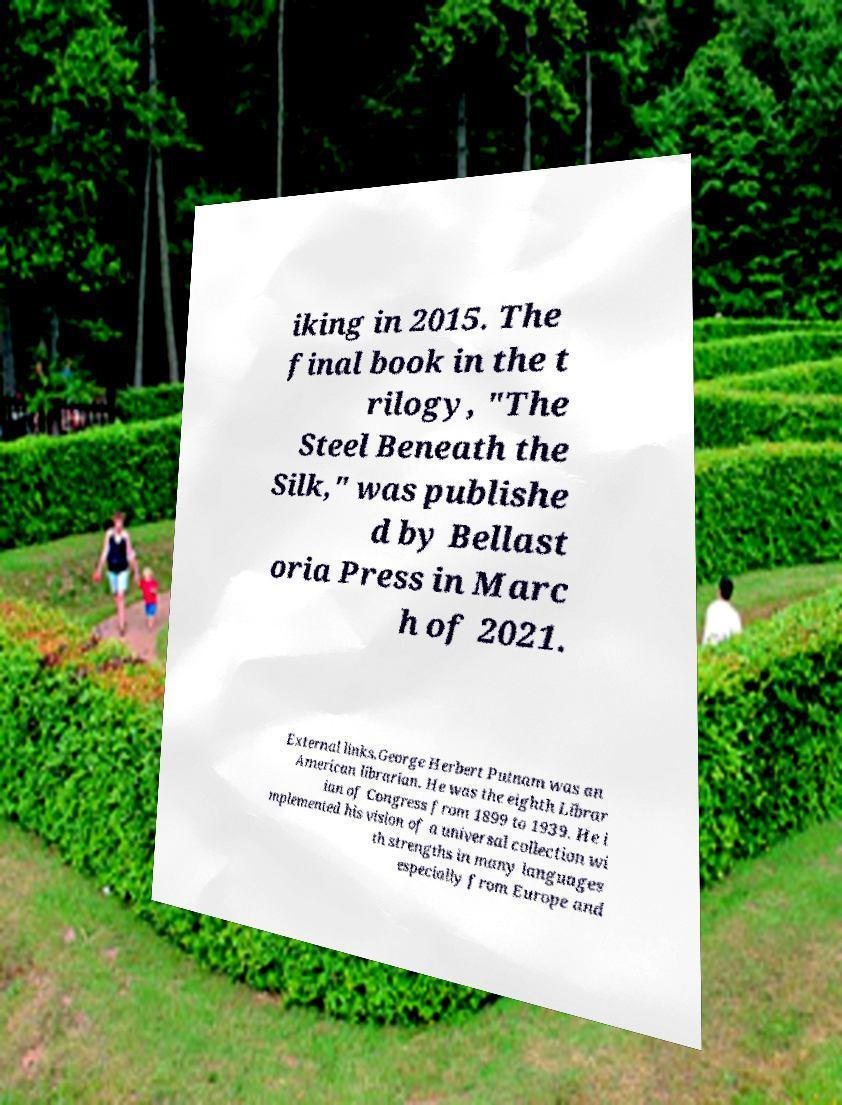I need the written content from this picture converted into text. Can you do that? iking in 2015. The final book in the t rilogy, "The Steel Beneath the Silk," was publishe d by Bellast oria Press in Marc h of 2021. External links.George Herbert Putnam was an American librarian. He was the eighth Librar ian of Congress from 1899 to 1939. He i mplemented his vision of a universal collection wi th strengths in many languages especially from Europe and 